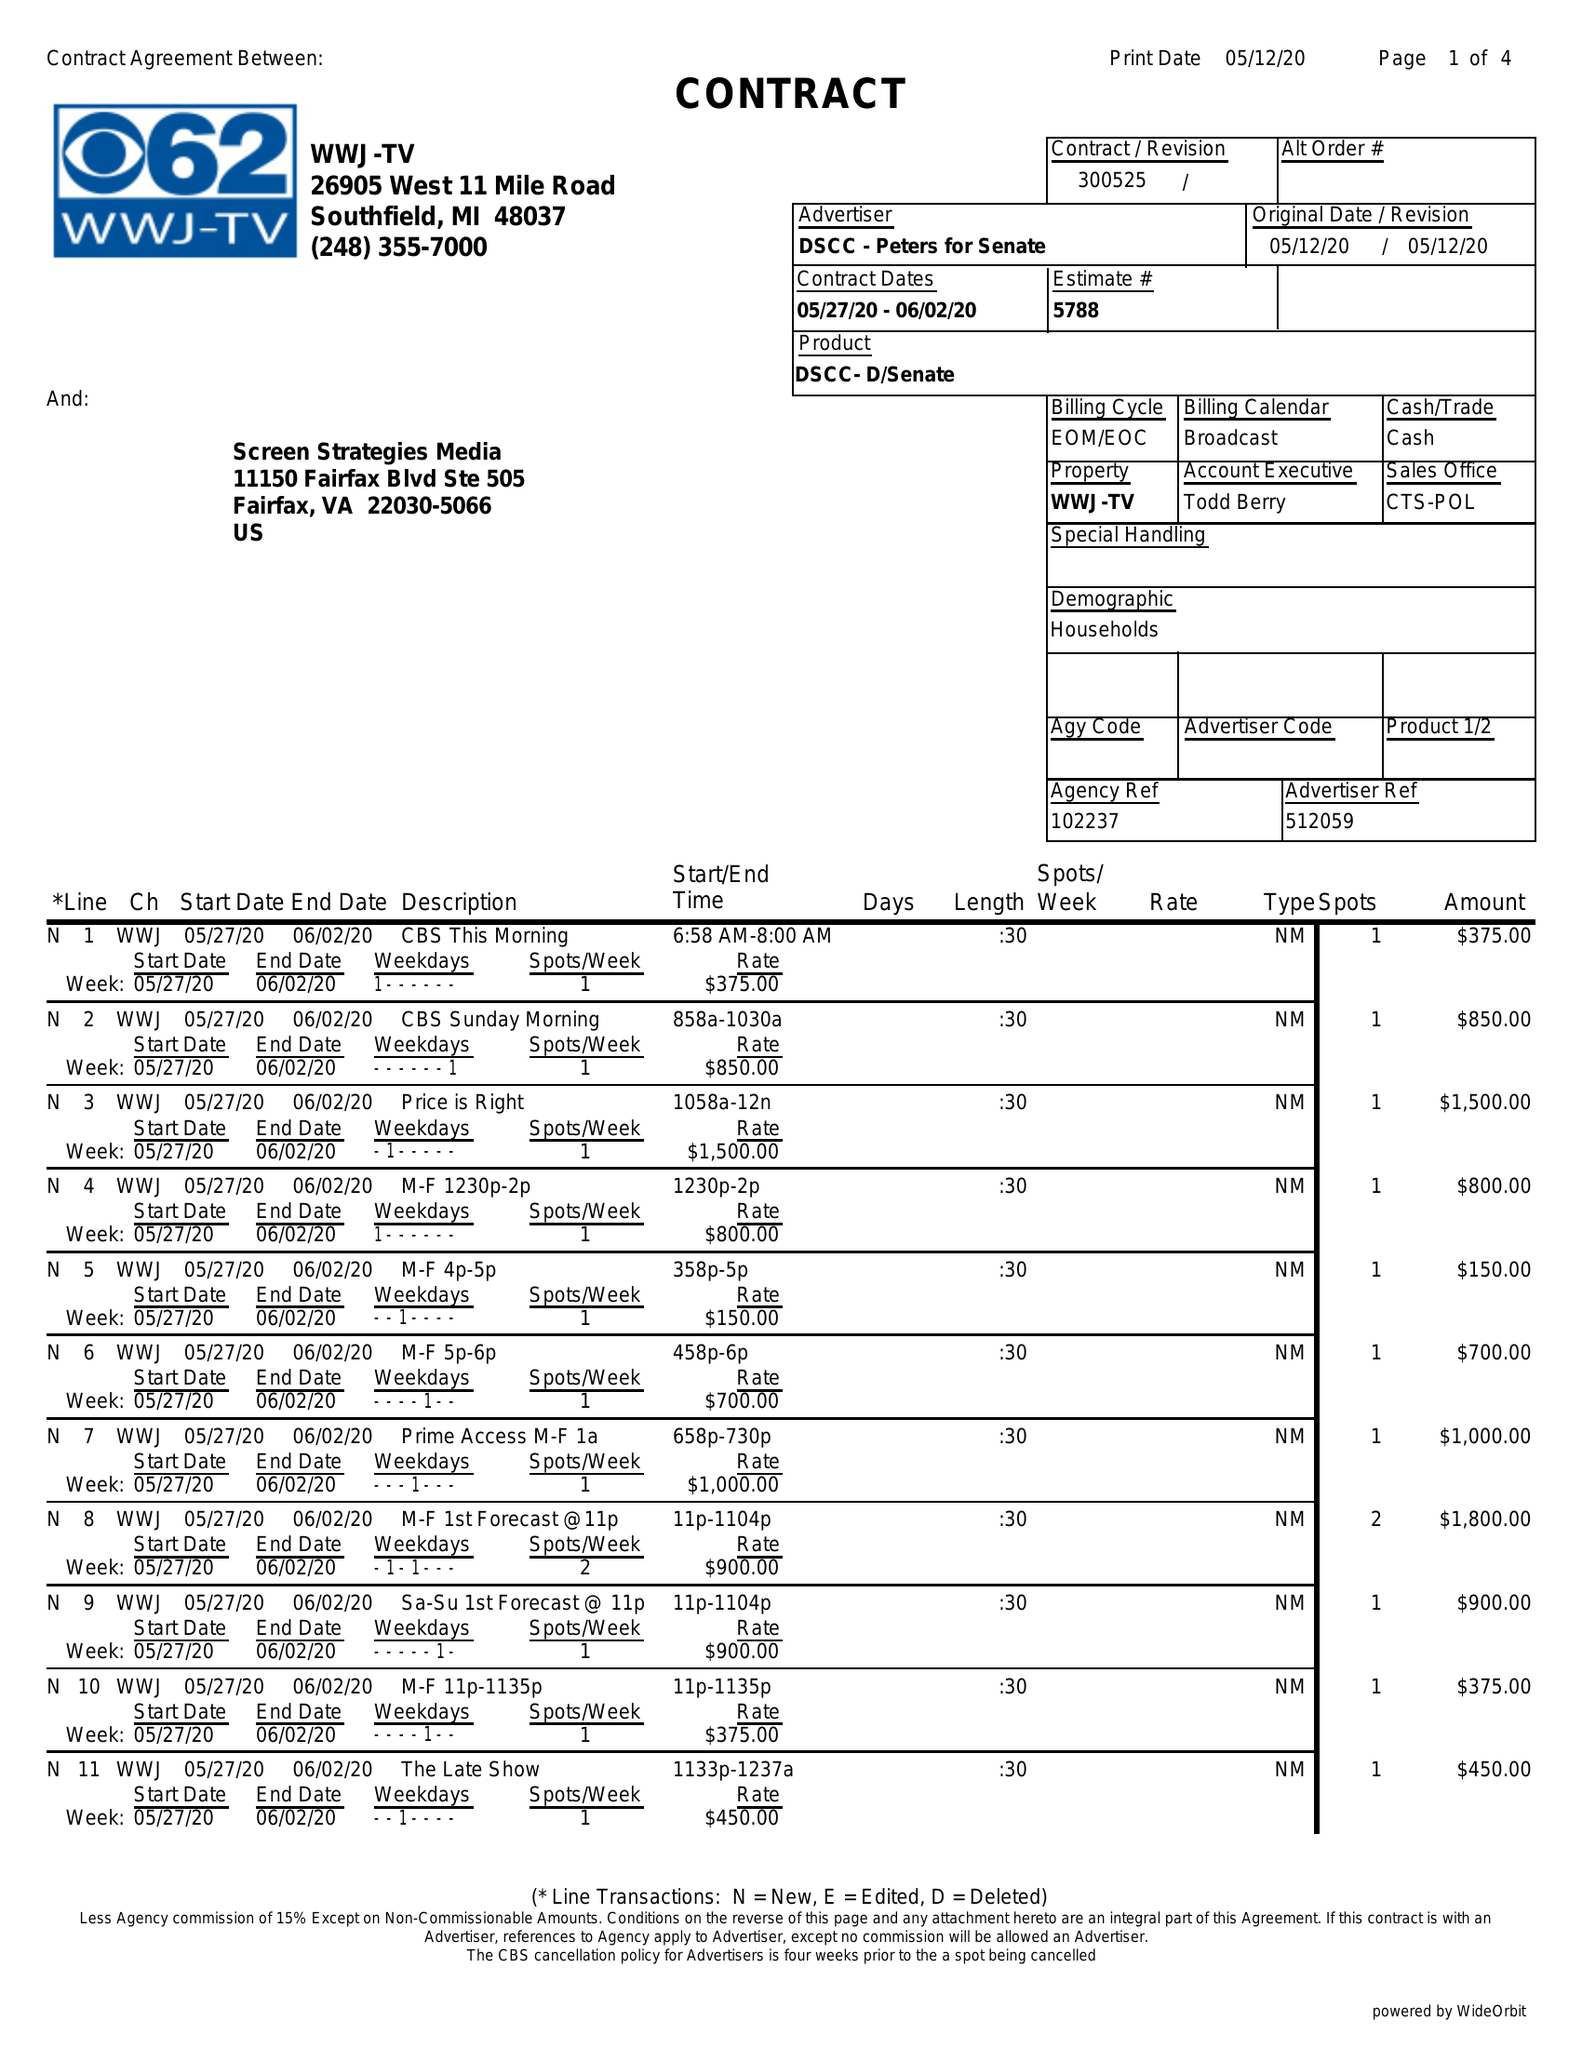What is the value for the contract_num?
Answer the question using a single word or phrase. 300525 